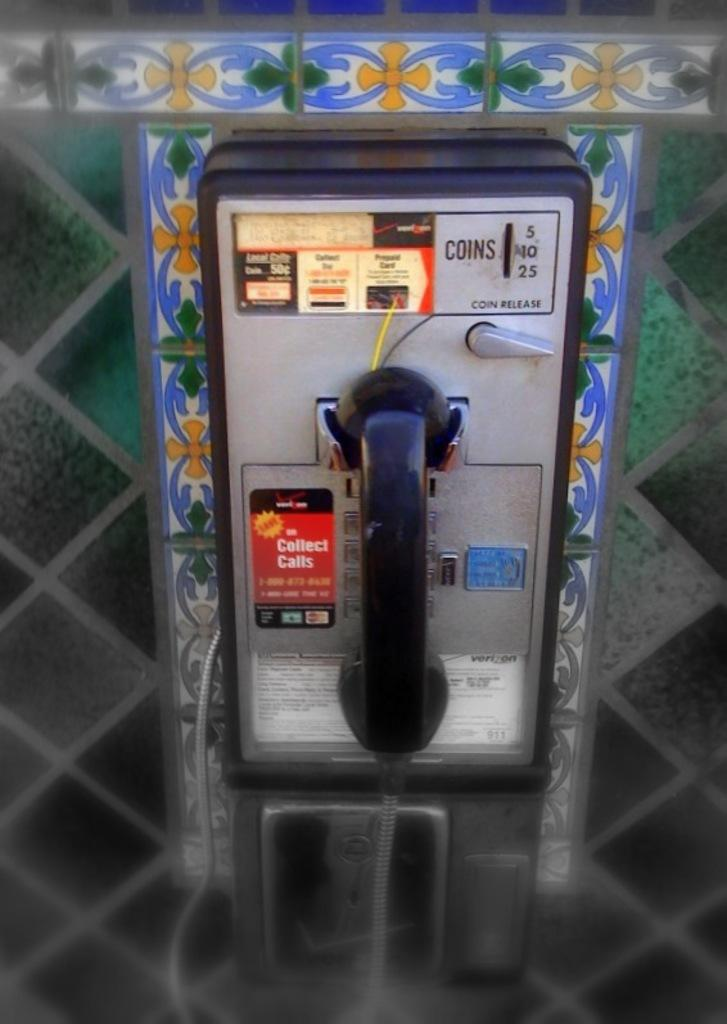Provide a one-sentence caption for the provided image. A pay phone has a sticker in red that says collect calls on it. 